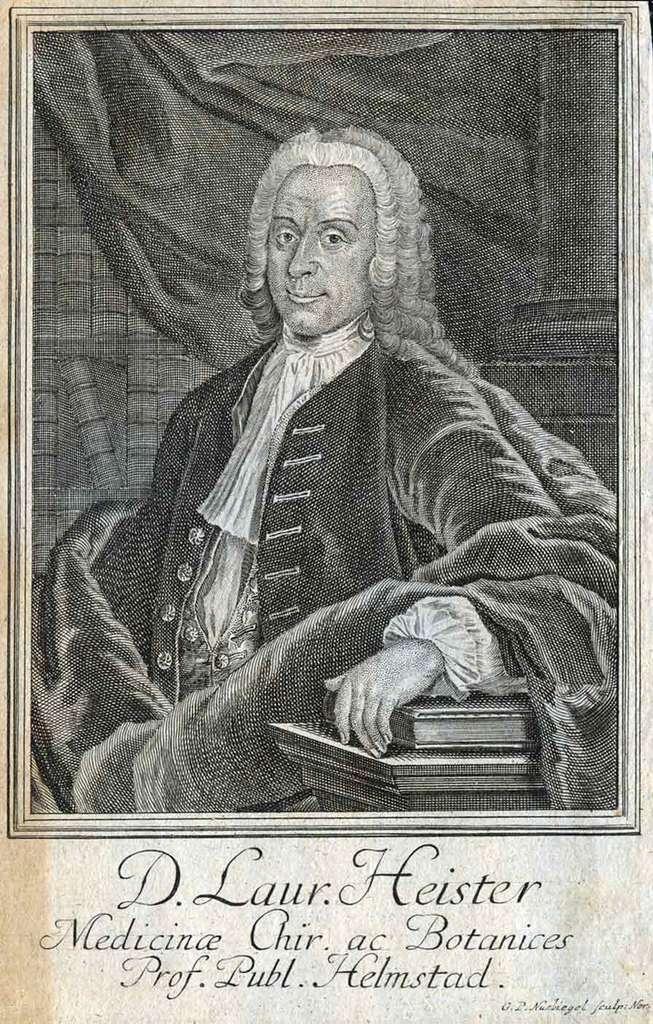How would you summarize this image in a sentence or two? Here I can see a picture of a person. Beside this person there are some books. At the bottom of this picture I can see some text. This is a black and white image. 